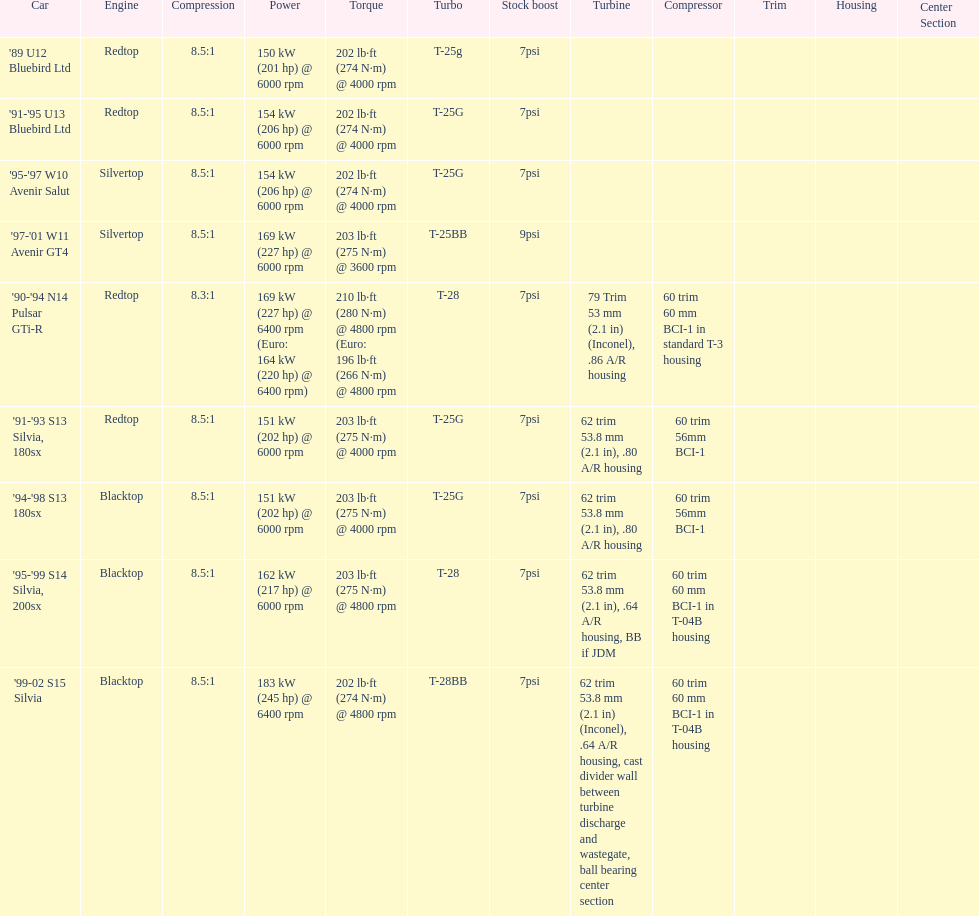How many models used the redtop engine? 4. 